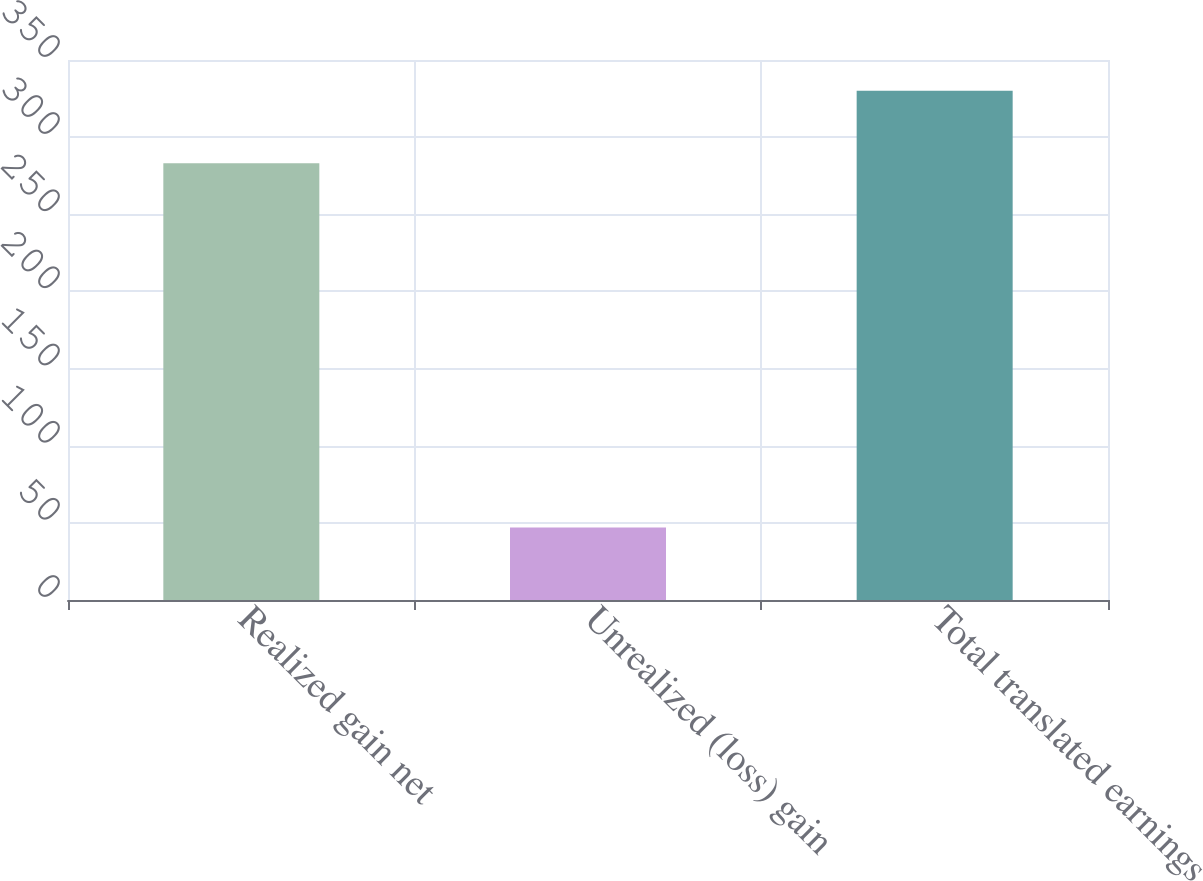<chart> <loc_0><loc_0><loc_500><loc_500><bar_chart><fcel>Realized gain net<fcel>Unrealized (loss) gain<fcel>Total translated earnings<nl><fcel>283<fcel>47<fcel>330<nl></chart> 